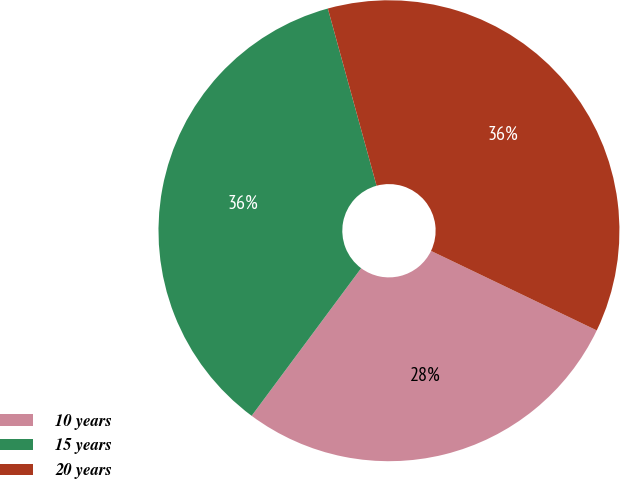Convert chart to OTSL. <chart><loc_0><loc_0><loc_500><loc_500><pie_chart><fcel>10 years<fcel>15 years<fcel>20 years<nl><fcel>28.04%<fcel>35.57%<fcel>36.39%<nl></chart> 